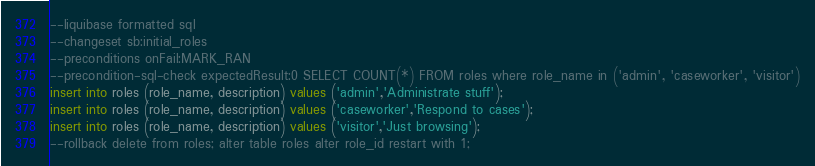<code> <loc_0><loc_0><loc_500><loc_500><_SQL_>--liquibase formatted sql
--changeset sb:initial_roles
--preconditions onFail:MARK_RAN
--precondition-sql-check expectedResult:0 SELECT COUNT(*) FROM roles where role_name in ('admin', 'caseworker', 'visitor')
insert into roles (role_name, description) values ('admin','Administrate stuff');
insert into roles (role_name, description) values ('caseworker','Respond to cases');
insert into roles (role_name, description) values ('visitor','Just browsing');
--rollback delete from roles; alter table roles alter role_id restart with 1;
</code> 